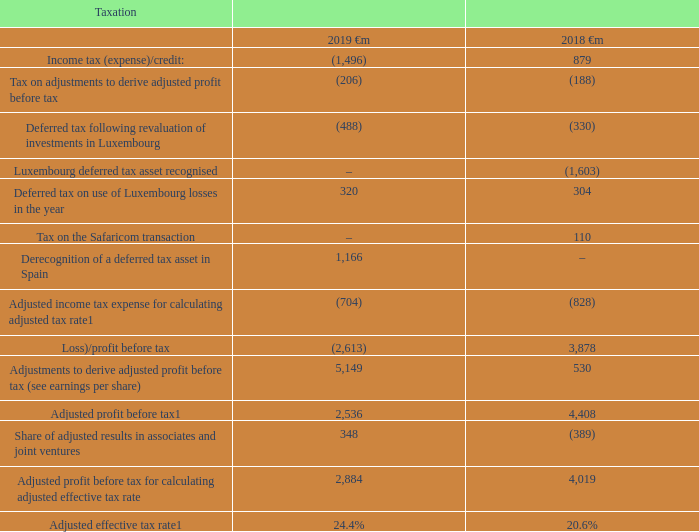Note: 1 See “Alternative performance measures” on page 231 for further details and reconciliations to the respective closest equivalent GAAP measure.
The Group’s adjusted effective tax rate for its controlled businesses for the year ended 31 March 2019 was 24.4% compared to 20.6% for the last financial year. The higher rate in the current year is primarily due to a change in the mix of the Group’s profit, driven by the financing for the Liberty Global transaction. The tax rate in the prior year also reflected the consequences of closing tax audits in Germany and Romania. We expect the Group’s adjusted effective tax rate to remain in the low-mid twenties range for the medium term.
The Group’s adjusted effective tax rate for both years does not include the following items: the derecognition of a deferred tax asset in Spain of €1,166 million (2018: €nil); deferred tax on the use of Luxembourg losses of €320 million (2018: €304 million); an increase in the deferred tax asset of €488 million (2018: €330 million) arising from a revaluation of investments based upon the local GAAP financial statements and tax returns.
The Group’s adjusted effective tax rate for the year ended 31 March 2018 does not include the recognition of a deferred tax asset of €1,603 million due to higher interest rates; and a tax charge in respect of capital gains on the transfer of share in Vodafone Kenya Limited to the Vodacom Group of €110 million.
What was the reason for a higher adjusted effective tax rate in 2019? Change in the mix of the group’s profit, driven by the financing for the liberty global transaction. How much is the income tax expense/credit in 2019?
Answer scale should be: million. (1,496). How much is the adjusted profit before tax in 2018?
Answer scale should be: million. 4,408. What is the average adjusted profit before tax?
Answer scale should be: million. (2,536+4,408)/2
Answer: 3472. Which year has a higher Adjusted effective tax rate? 24.4% > 20.6%
Answer: 2019. What is the average deferred tax on use of luxembourg losses?
Answer scale should be: million. (320+304)/2
Answer: 312. 